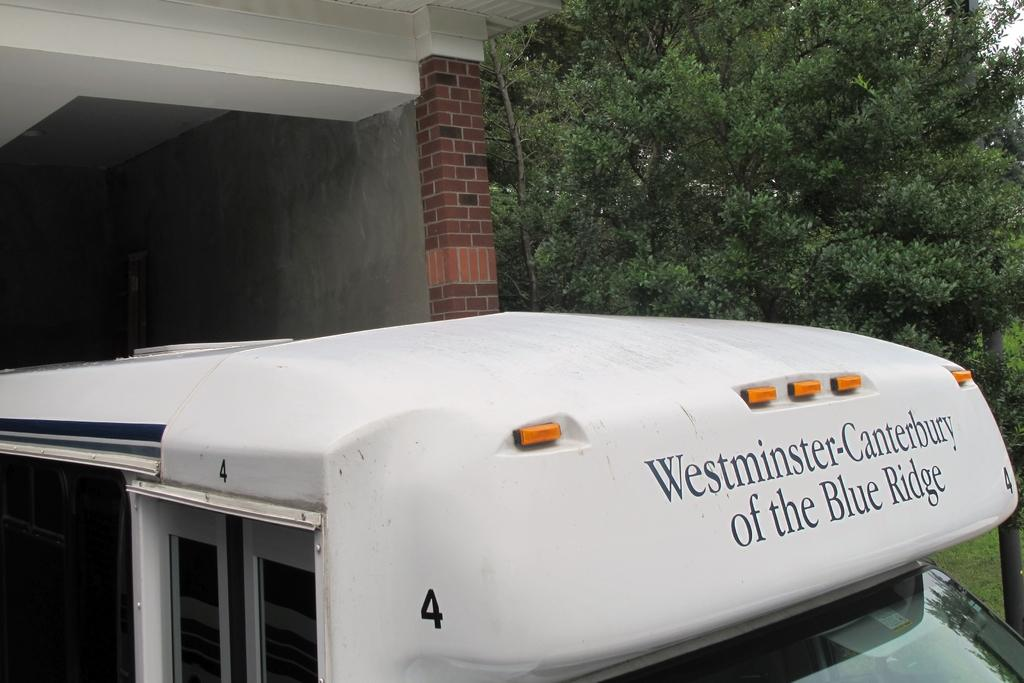What is the color of the vehicle in the image? The vehicle in the image is white. What can be seen in the background of the image? There is a room visible in the background of the image. What type of vegetation is on the right side of the image? There are green color trees on the right side of the image. Can you see a glove hanging from the tree in the image? There is no glove present in the image; it only features a white color vehicle, a room in the background, and green color trees on the right side. 